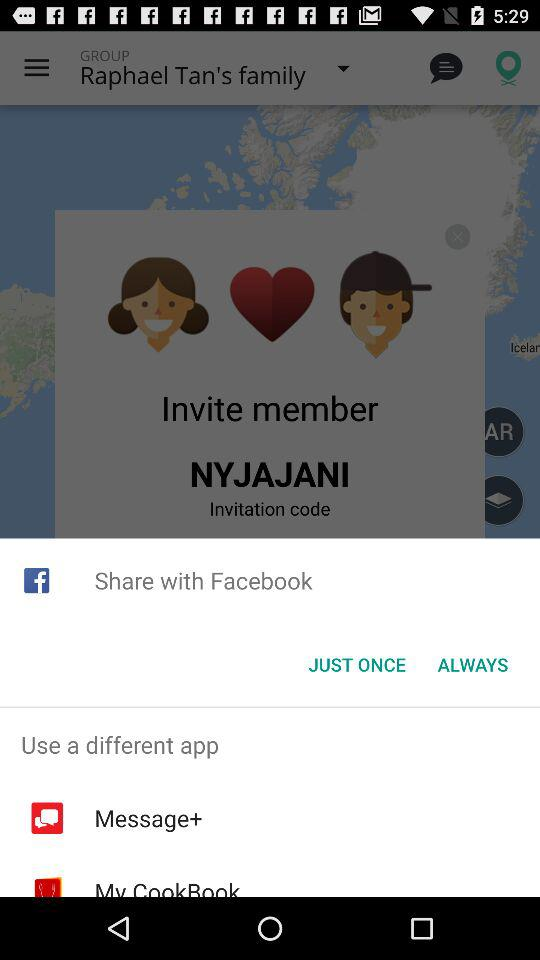What are the different application options to use? The different applications are "Message+" and "MyCookBook". 